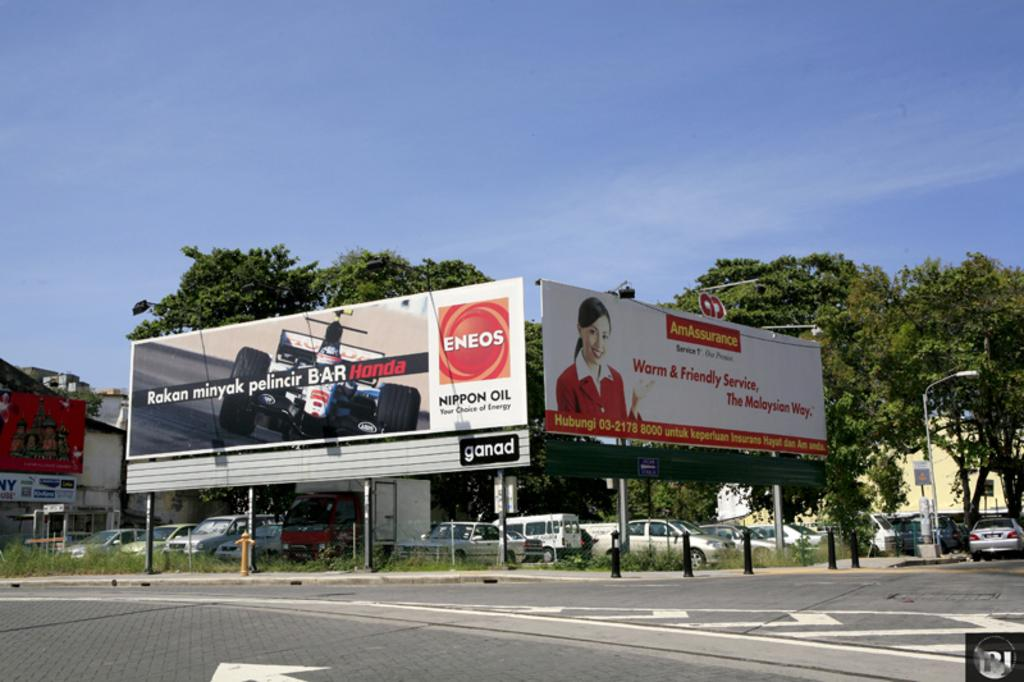What is located in the center of the image? There are hoardings in the center of the image. What can be seen at the bottom of the image? There are cars and poles at the bottom of the image. What is visible in the background of the image? There are trees, sheds, and the sky visible in the background of the image. Can you see any apples hanging from the trees in the image? There are no apples visible in the image; only trees are present in the background. Are there any stars visible in the sky in the image? The sky is visible in the background of the image, but there are no stars mentioned or visible in the image. 